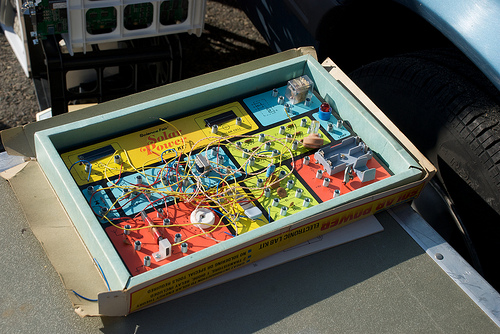<image>
Is the wires on the table? No. The wires is not positioned on the table. They may be near each other, but the wires is not supported by or resting on top of the table. 